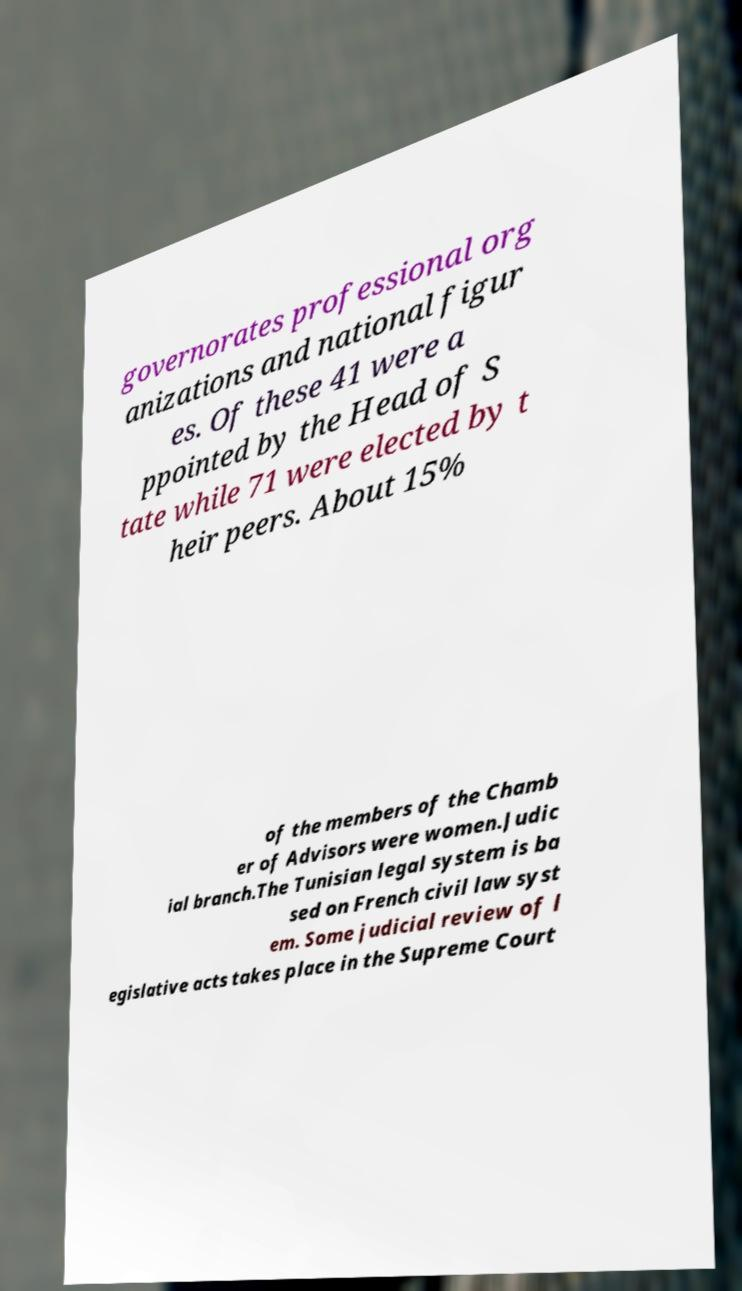Can you accurately transcribe the text from the provided image for me? governorates professional org anizations and national figur es. Of these 41 were a ppointed by the Head of S tate while 71 were elected by t heir peers. About 15% of the members of the Chamb er of Advisors were women.Judic ial branch.The Tunisian legal system is ba sed on French civil law syst em. Some judicial review of l egislative acts takes place in the Supreme Court 